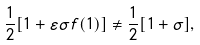<formula> <loc_0><loc_0><loc_500><loc_500>\frac { 1 } { 2 } { \left [ 1 + \varepsilon \sigma f ( 1 ) \right ] } \neq \frac { 1 } { 2 } { \left [ 1 + \sigma \right ] } ,</formula> 